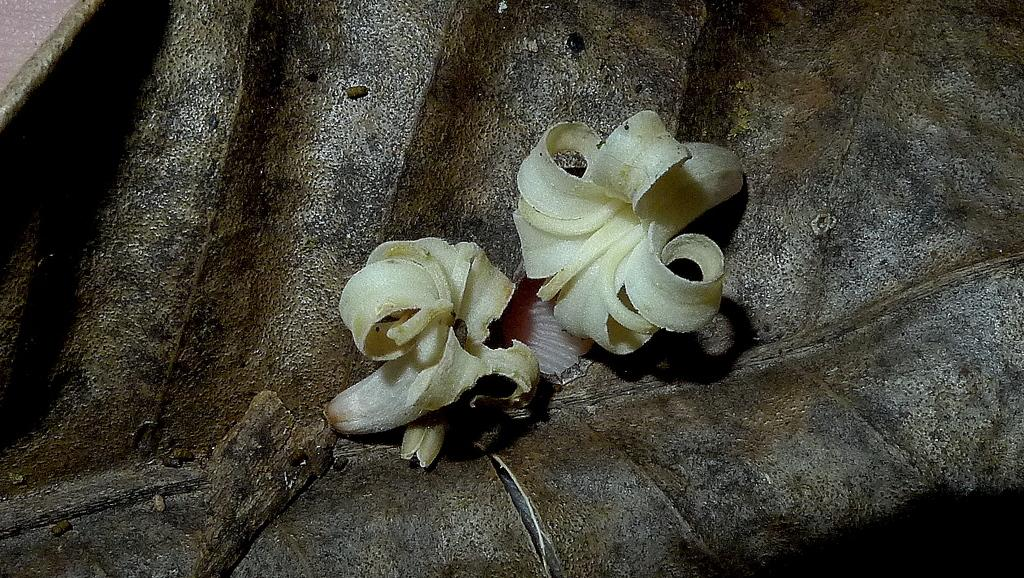What is the main subject in the center of the image? There are flowers in the center of the image. Can you describe anything in the background of the image? There is an object in the background of the image. What type of hate can be seen in the image? There is no hate present in the image; it features flowers and an object in the background. What is the front of the hall like in the image? There is no hall present in the image, so it is not possible to describe the front of a hall. 